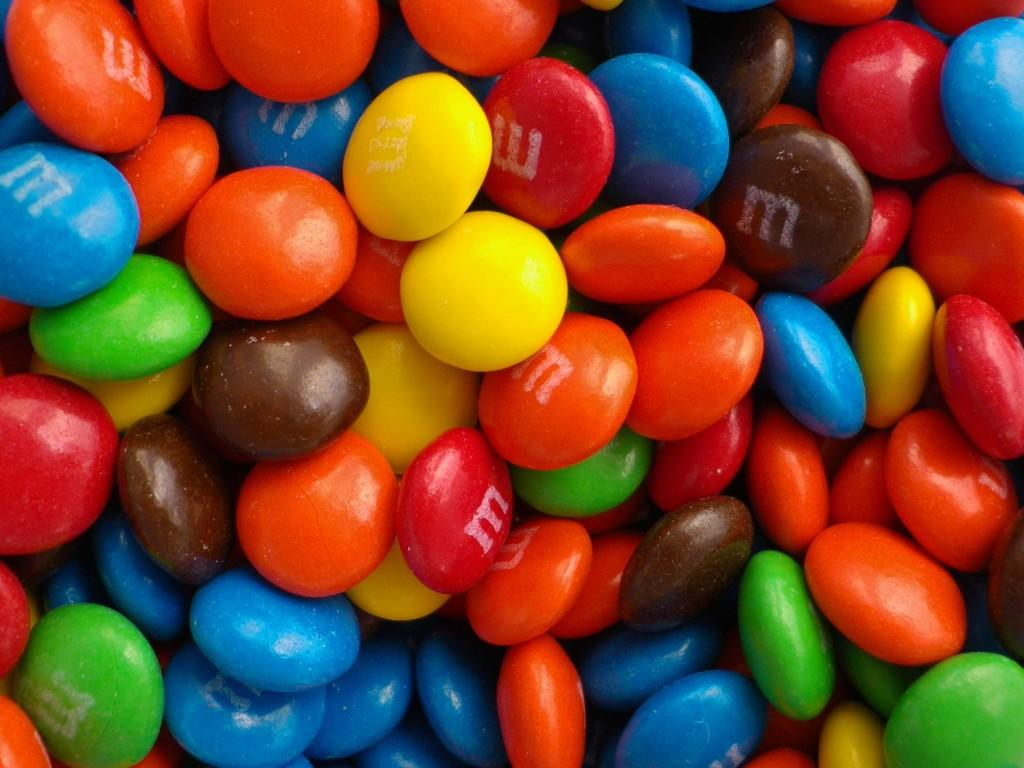What type of food is visible in the image? There are chocolates in the image. What type of tool is used to tighten bolts in the image? There is no tool or bolts present in the image; it only features chocolates. 